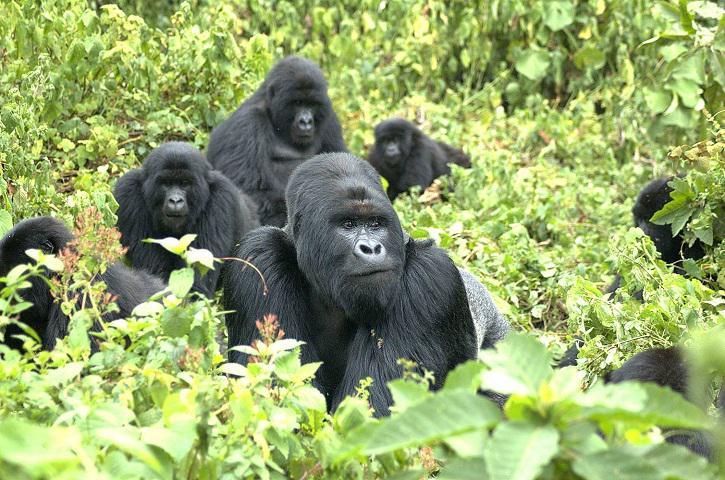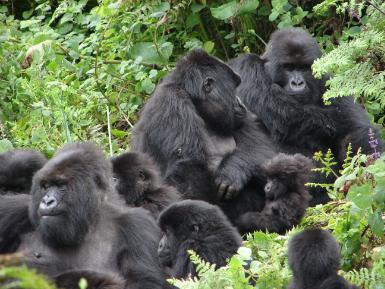The first image is the image on the left, the second image is the image on the right. For the images shown, is this caption "An image shows exactly one gorilla, which is posed with its chest facing the camera." true? Answer yes or no. No. The first image is the image on the left, the second image is the image on the right. Examine the images to the left and right. Is the description "The right image contains no more than two gorillas." accurate? Answer yes or no. No. 